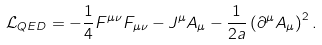<formula> <loc_0><loc_0><loc_500><loc_500>\mathcal { L } _ { Q E D } = - \frac { 1 } { 4 } F ^ { \mu \nu } F _ { \mu \nu } - J ^ { \mu } A _ { \mu } - \frac { 1 } { 2 a } \left ( \partial ^ { \mu } A _ { \mu } \right ) ^ { 2 } .</formula> 